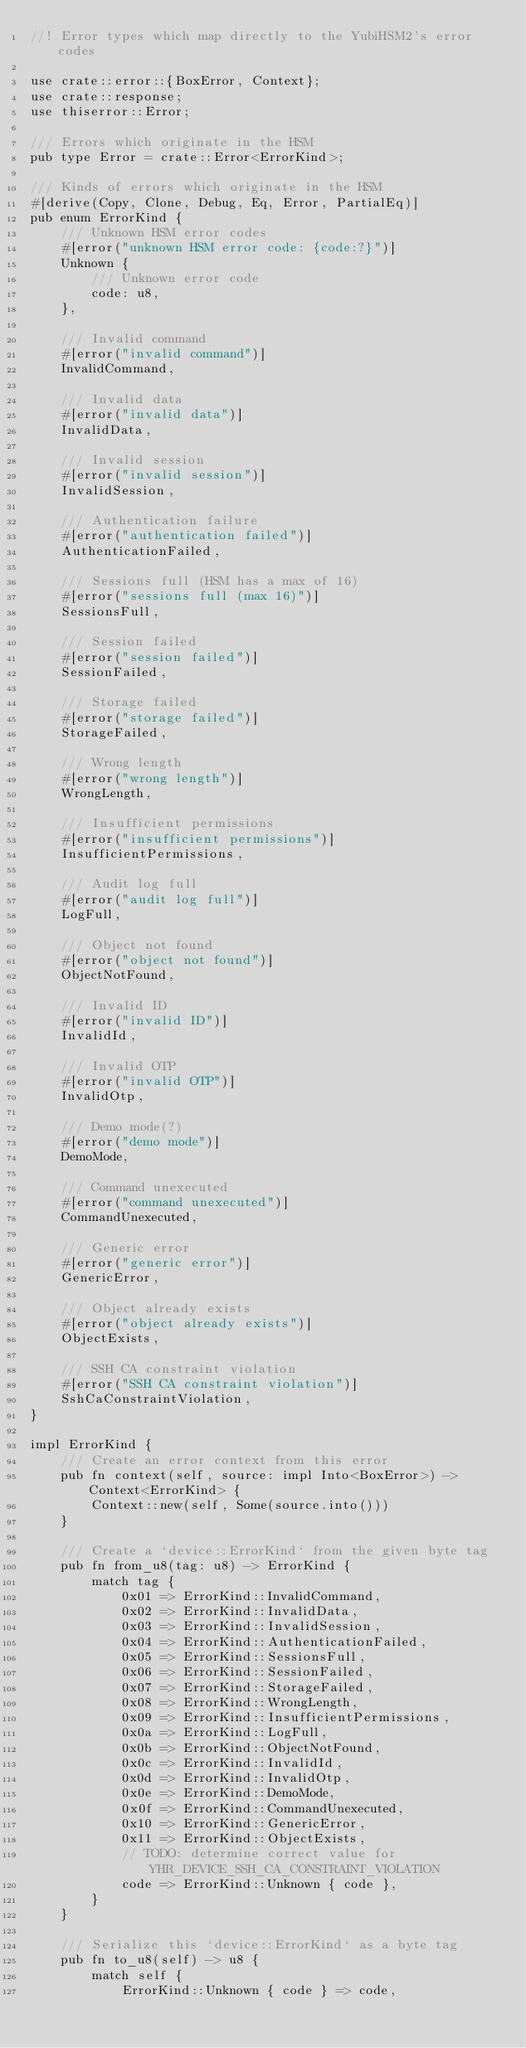Convert code to text. <code><loc_0><loc_0><loc_500><loc_500><_Rust_>//! Error types which map directly to the YubiHSM2's error codes

use crate::error::{BoxError, Context};
use crate::response;
use thiserror::Error;

/// Errors which originate in the HSM
pub type Error = crate::Error<ErrorKind>;

/// Kinds of errors which originate in the HSM
#[derive(Copy, Clone, Debug, Eq, Error, PartialEq)]
pub enum ErrorKind {
    /// Unknown HSM error codes
    #[error("unknown HSM error code: {code:?}")]
    Unknown {
        /// Unknown error code
        code: u8,
    },

    /// Invalid command
    #[error("invalid command")]
    InvalidCommand,

    /// Invalid data
    #[error("invalid data")]
    InvalidData,

    /// Invalid session
    #[error("invalid session")]
    InvalidSession,

    /// Authentication failure
    #[error("authentication failed")]
    AuthenticationFailed,

    /// Sessions full (HSM has a max of 16)
    #[error("sessions full (max 16)")]
    SessionsFull,

    /// Session failed
    #[error("session failed")]
    SessionFailed,

    /// Storage failed
    #[error("storage failed")]
    StorageFailed,

    /// Wrong length
    #[error("wrong length")]
    WrongLength,

    /// Insufficient permissions
    #[error("insufficient permissions")]
    InsufficientPermissions,

    /// Audit log full
    #[error("audit log full")]
    LogFull,

    /// Object not found
    #[error("object not found")]
    ObjectNotFound,

    /// Invalid ID
    #[error("invalid ID")]
    InvalidId,

    /// Invalid OTP
    #[error("invalid OTP")]
    InvalidOtp,

    /// Demo mode(?)
    #[error("demo mode")]
    DemoMode,

    /// Command unexecuted
    #[error("command unexecuted")]
    CommandUnexecuted,

    /// Generic error
    #[error("generic error")]
    GenericError,

    /// Object already exists
    #[error("object already exists")]
    ObjectExists,

    /// SSH CA constraint violation
    #[error("SSH CA constraint violation")]
    SshCaConstraintViolation,
}

impl ErrorKind {
    /// Create an error context from this error
    pub fn context(self, source: impl Into<BoxError>) -> Context<ErrorKind> {
        Context::new(self, Some(source.into()))
    }

    /// Create a `device::ErrorKind` from the given byte tag
    pub fn from_u8(tag: u8) -> ErrorKind {
        match tag {
            0x01 => ErrorKind::InvalidCommand,
            0x02 => ErrorKind::InvalidData,
            0x03 => ErrorKind::InvalidSession,
            0x04 => ErrorKind::AuthenticationFailed,
            0x05 => ErrorKind::SessionsFull,
            0x06 => ErrorKind::SessionFailed,
            0x07 => ErrorKind::StorageFailed,
            0x08 => ErrorKind::WrongLength,
            0x09 => ErrorKind::InsufficientPermissions,
            0x0a => ErrorKind::LogFull,
            0x0b => ErrorKind::ObjectNotFound,
            0x0c => ErrorKind::InvalidId,
            0x0d => ErrorKind::InvalidOtp,
            0x0e => ErrorKind::DemoMode,
            0x0f => ErrorKind::CommandUnexecuted,
            0x10 => ErrorKind::GenericError,
            0x11 => ErrorKind::ObjectExists,
            // TODO: determine correct value for YHR_DEVICE_SSH_CA_CONSTRAINT_VIOLATION
            code => ErrorKind::Unknown { code },
        }
    }

    /// Serialize this `device::ErrorKind` as a byte tag
    pub fn to_u8(self) -> u8 {
        match self {
            ErrorKind::Unknown { code } => code,</code> 